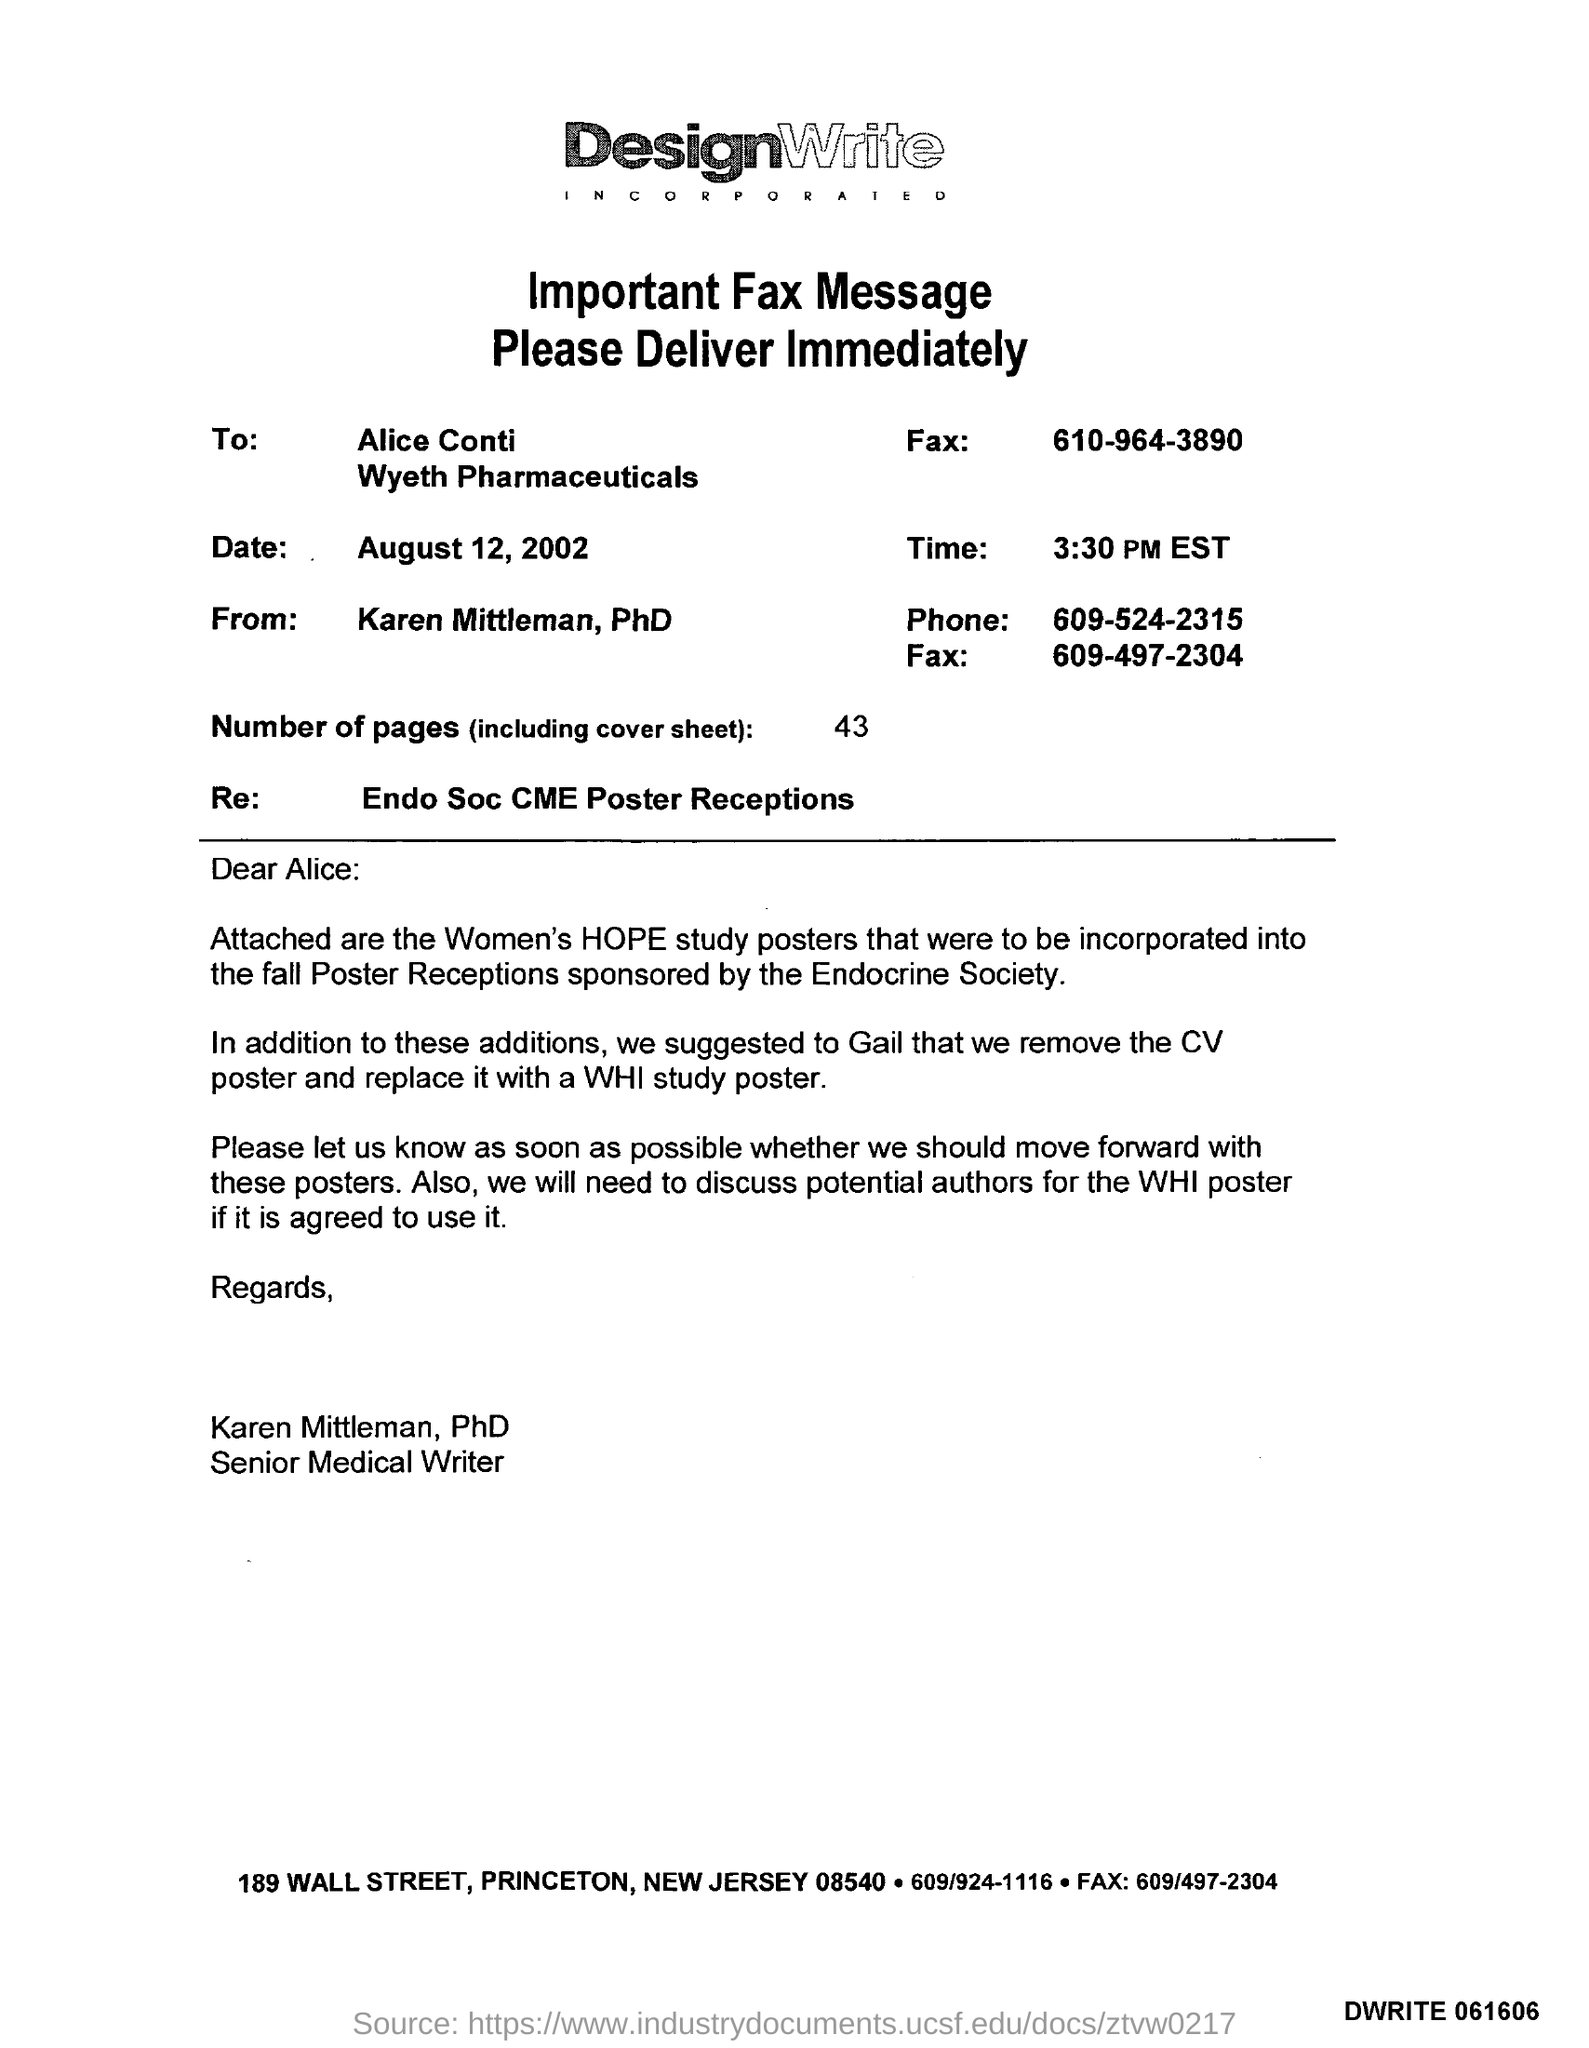What is the phone number mentioned in the fax ?
Your answer should be compact. 609-524-2315. How many number of pages are there (including cover sheet )?
Ensure brevity in your answer.  43. What is the re mentioned in the given mail ?
Ensure brevity in your answer.  Endo Soc CME Poster Receptions. What is the designation of karen mittleman ?
Your response must be concise. Senior Medical Writer. What is the time mentioned in the given fax message ?
Your answer should be compact. 3:30 PM EST. 